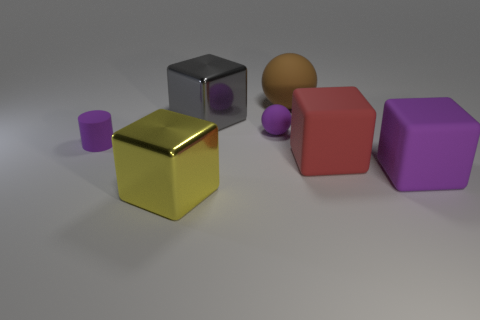Are the large red object that is in front of the gray metallic cube and the small purple cylinder made of the same material? While they may appear different due to their colors and sizes, the large red object and the small purple cylinder indeed seem to be made of the same matte material, judging by the way light is diffused on their surfaces in a similar manner. 